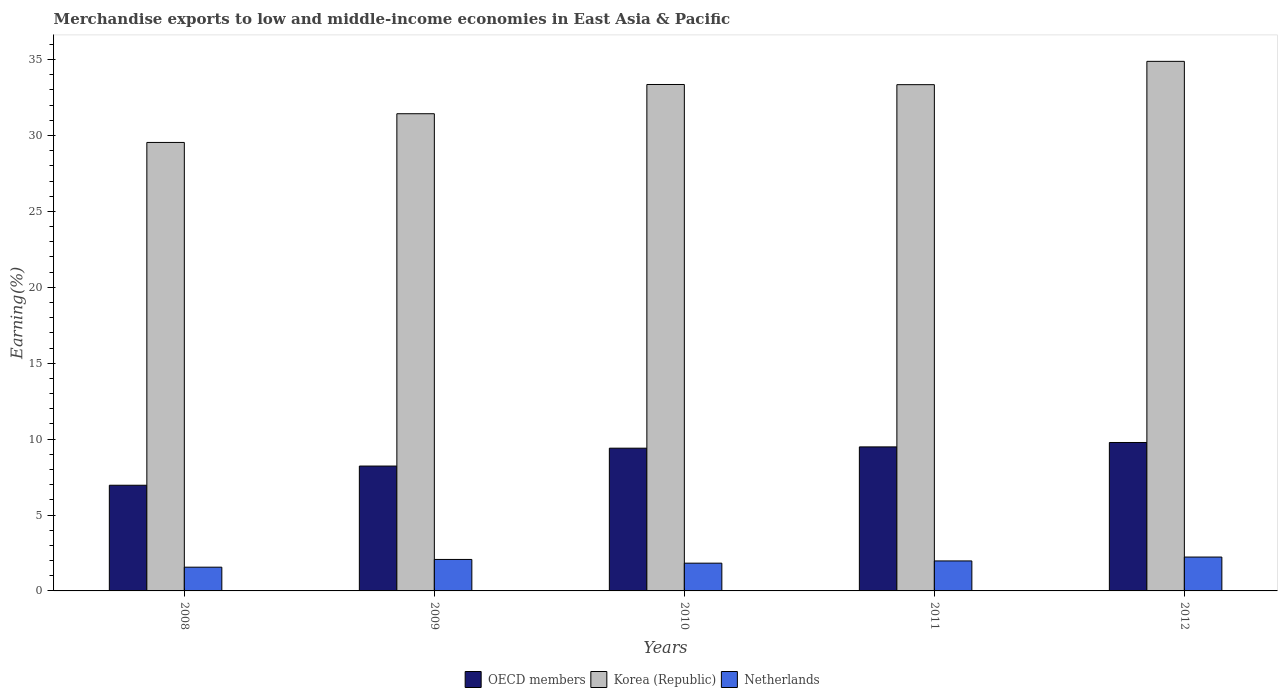How many different coloured bars are there?
Make the answer very short. 3. How many groups of bars are there?
Provide a short and direct response. 5. How many bars are there on the 1st tick from the left?
Your answer should be very brief. 3. What is the percentage of amount earned from merchandise exports in OECD members in 2012?
Offer a terse response. 9.78. Across all years, what is the maximum percentage of amount earned from merchandise exports in OECD members?
Offer a terse response. 9.78. Across all years, what is the minimum percentage of amount earned from merchandise exports in Korea (Republic)?
Keep it short and to the point. 29.54. In which year was the percentage of amount earned from merchandise exports in Netherlands minimum?
Keep it short and to the point. 2008. What is the total percentage of amount earned from merchandise exports in OECD members in the graph?
Ensure brevity in your answer.  43.85. What is the difference between the percentage of amount earned from merchandise exports in Netherlands in 2009 and that in 2011?
Offer a very short reply. 0.1. What is the difference between the percentage of amount earned from merchandise exports in Korea (Republic) in 2008 and the percentage of amount earned from merchandise exports in OECD members in 2009?
Make the answer very short. 21.32. What is the average percentage of amount earned from merchandise exports in Korea (Republic) per year?
Keep it short and to the point. 32.51. In the year 2009, what is the difference between the percentage of amount earned from merchandise exports in Korea (Republic) and percentage of amount earned from merchandise exports in Netherlands?
Offer a terse response. 29.36. What is the ratio of the percentage of amount earned from merchandise exports in Netherlands in 2010 to that in 2011?
Provide a succinct answer. 0.93. Is the difference between the percentage of amount earned from merchandise exports in Korea (Republic) in 2009 and 2010 greater than the difference between the percentage of amount earned from merchandise exports in Netherlands in 2009 and 2010?
Provide a short and direct response. No. What is the difference between the highest and the second highest percentage of amount earned from merchandise exports in OECD members?
Give a very brief answer. 0.29. What is the difference between the highest and the lowest percentage of amount earned from merchandise exports in Netherlands?
Your answer should be compact. 0.67. What does the 3rd bar from the left in 2011 represents?
Your answer should be compact. Netherlands. What does the 2nd bar from the right in 2011 represents?
Your answer should be compact. Korea (Republic). Is it the case that in every year, the sum of the percentage of amount earned from merchandise exports in Korea (Republic) and percentage of amount earned from merchandise exports in Netherlands is greater than the percentage of amount earned from merchandise exports in OECD members?
Provide a succinct answer. Yes. How many bars are there?
Offer a very short reply. 15. Are the values on the major ticks of Y-axis written in scientific E-notation?
Offer a very short reply. No. Does the graph contain grids?
Provide a succinct answer. No. Where does the legend appear in the graph?
Your answer should be compact. Bottom center. How many legend labels are there?
Your answer should be compact. 3. What is the title of the graph?
Keep it short and to the point. Merchandise exports to low and middle-income economies in East Asia & Pacific. What is the label or title of the X-axis?
Your answer should be very brief. Years. What is the label or title of the Y-axis?
Your answer should be compact. Earning(%). What is the Earning(%) of OECD members in 2008?
Give a very brief answer. 6.96. What is the Earning(%) of Korea (Republic) in 2008?
Keep it short and to the point. 29.54. What is the Earning(%) in Netherlands in 2008?
Your response must be concise. 1.56. What is the Earning(%) of OECD members in 2009?
Provide a short and direct response. 8.22. What is the Earning(%) of Korea (Republic) in 2009?
Your answer should be very brief. 31.43. What is the Earning(%) in Netherlands in 2009?
Your answer should be very brief. 2.07. What is the Earning(%) in OECD members in 2010?
Keep it short and to the point. 9.4. What is the Earning(%) in Korea (Republic) in 2010?
Ensure brevity in your answer.  33.36. What is the Earning(%) in Netherlands in 2010?
Make the answer very short. 1.83. What is the Earning(%) of OECD members in 2011?
Offer a terse response. 9.49. What is the Earning(%) of Korea (Republic) in 2011?
Offer a terse response. 33.35. What is the Earning(%) in Netherlands in 2011?
Offer a terse response. 1.98. What is the Earning(%) in OECD members in 2012?
Give a very brief answer. 9.78. What is the Earning(%) of Korea (Republic) in 2012?
Ensure brevity in your answer.  34.88. What is the Earning(%) of Netherlands in 2012?
Your answer should be very brief. 2.23. Across all years, what is the maximum Earning(%) of OECD members?
Give a very brief answer. 9.78. Across all years, what is the maximum Earning(%) of Korea (Republic)?
Keep it short and to the point. 34.88. Across all years, what is the maximum Earning(%) in Netherlands?
Offer a terse response. 2.23. Across all years, what is the minimum Earning(%) of OECD members?
Your answer should be very brief. 6.96. Across all years, what is the minimum Earning(%) in Korea (Republic)?
Your response must be concise. 29.54. Across all years, what is the minimum Earning(%) of Netherlands?
Offer a terse response. 1.56. What is the total Earning(%) in OECD members in the graph?
Your answer should be compact. 43.85. What is the total Earning(%) in Korea (Republic) in the graph?
Your answer should be very brief. 162.56. What is the total Earning(%) of Netherlands in the graph?
Your answer should be compact. 9.67. What is the difference between the Earning(%) in OECD members in 2008 and that in 2009?
Offer a terse response. -1.26. What is the difference between the Earning(%) of Korea (Republic) in 2008 and that in 2009?
Offer a very short reply. -1.89. What is the difference between the Earning(%) in Netherlands in 2008 and that in 2009?
Keep it short and to the point. -0.51. What is the difference between the Earning(%) of OECD members in 2008 and that in 2010?
Your answer should be compact. -2.44. What is the difference between the Earning(%) of Korea (Republic) in 2008 and that in 2010?
Keep it short and to the point. -3.82. What is the difference between the Earning(%) in Netherlands in 2008 and that in 2010?
Your response must be concise. -0.26. What is the difference between the Earning(%) of OECD members in 2008 and that in 2011?
Provide a succinct answer. -2.53. What is the difference between the Earning(%) of Korea (Republic) in 2008 and that in 2011?
Make the answer very short. -3.81. What is the difference between the Earning(%) in Netherlands in 2008 and that in 2011?
Your response must be concise. -0.41. What is the difference between the Earning(%) in OECD members in 2008 and that in 2012?
Your answer should be very brief. -2.82. What is the difference between the Earning(%) in Korea (Republic) in 2008 and that in 2012?
Ensure brevity in your answer.  -5.34. What is the difference between the Earning(%) in Netherlands in 2008 and that in 2012?
Your answer should be compact. -0.67. What is the difference between the Earning(%) in OECD members in 2009 and that in 2010?
Provide a succinct answer. -1.18. What is the difference between the Earning(%) in Korea (Republic) in 2009 and that in 2010?
Provide a succinct answer. -1.93. What is the difference between the Earning(%) in Netherlands in 2009 and that in 2010?
Your answer should be very brief. 0.24. What is the difference between the Earning(%) of OECD members in 2009 and that in 2011?
Give a very brief answer. -1.26. What is the difference between the Earning(%) of Korea (Republic) in 2009 and that in 2011?
Keep it short and to the point. -1.91. What is the difference between the Earning(%) in Netherlands in 2009 and that in 2011?
Provide a succinct answer. 0.1. What is the difference between the Earning(%) in OECD members in 2009 and that in 2012?
Provide a short and direct response. -1.55. What is the difference between the Earning(%) of Korea (Republic) in 2009 and that in 2012?
Ensure brevity in your answer.  -3.45. What is the difference between the Earning(%) in Netherlands in 2009 and that in 2012?
Your answer should be very brief. -0.16. What is the difference between the Earning(%) in OECD members in 2010 and that in 2011?
Provide a short and direct response. -0.08. What is the difference between the Earning(%) of Korea (Republic) in 2010 and that in 2011?
Provide a succinct answer. 0.01. What is the difference between the Earning(%) of Netherlands in 2010 and that in 2011?
Your answer should be very brief. -0.15. What is the difference between the Earning(%) in OECD members in 2010 and that in 2012?
Your answer should be compact. -0.37. What is the difference between the Earning(%) in Korea (Republic) in 2010 and that in 2012?
Your answer should be very brief. -1.52. What is the difference between the Earning(%) of Netherlands in 2010 and that in 2012?
Provide a short and direct response. -0.4. What is the difference between the Earning(%) in OECD members in 2011 and that in 2012?
Give a very brief answer. -0.29. What is the difference between the Earning(%) of Korea (Republic) in 2011 and that in 2012?
Offer a terse response. -1.54. What is the difference between the Earning(%) in Netherlands in 2011 and that in 2012?
Offer a terse response. -0.26. What is the difference between the Earning(%) in OECD members in 2008 and the Earning(%) in Korea (Republic) in 2009?
Give a very brief answer. -24.47. What is the difference between the Earning(%) in OECD members in 2008 and the Earning(%) in Netherlands in 2009?
Keep it short and to the point. 4.89. What is the difference between the Earning(%) of Korea (Republic) in 2008 and the Earning(%) of Netherlands in 2009?
Your answer should be compact. 27.47. What is the difference between the Earning(%) of OECD members in 2008 and the Earning(%) of Korea (Republic) in 2010?
Keep it short and to the point. -26.4. What is the difference between the Earning(%) of OECD members in 2008 and the Earning(%) of Netherlands in 2010?
Give a very brief answer. 5.13. What is the difference between the Earning(%) in Korea (Republic) in 2008 and the Earning(%) in Netherlands in 2010?
Offer a terse response. 27.71. What is the difference between the Earning(%) in OECD members in 2008 and the Earning(%) in Korea (Republic) in 2011?
Make the answer very short. -26.38. What is the difference between the Earning(%) of OECD members in 2008 and the Earning(%) of Netherlands in 2011?
Make the answer very short. 4.99. What is the difference between the Earning(%) in Korea (Republic) in 2008 and the Earning(%) in Netherlands in 2011?
Keep it short and to the point. 27.56. What is the difference between the Earning(%) in OECD members in 2008 and the Earning(%) in Korea (Republic) in 2012?
Your response must be concise. -27.92. What is the difference between the Earning(%) of OECD members in 2008 and the Earning(%) of Netherlands in 2012?
Make the answer very short. 4.73. What is the difference between the Earning(%) of Korea (Republic) in 2008 and the Earning(%) of Netherlands in 2012?
Your answer should be compact. 27.31. What is the difference between the Earning(%) in OECD members in 2009 and the Earning(%) in Korea (Republic) in 2010?
Your response must be concise. -25.13. What is the difference between the Earning(%) in OECD members in 2009 and the Earning(%) in Netherlands in 2010?
Offer a very short reply. 6.4. What is the difference between the Earning(%) in Korea (Republic) in 2009 and the Earning(%) in Netherlands in 2010?
Offer a terse response. 29.6. What is the difference between the Earning(%) in OECD members in 2009 and the Earning(%) in Korea (Republic) in 2011?
Your answer should be very brief. -25.12. What is the difference between the Earning(%) of OECD members in 2009 and the Earning(%) of Netherlands in 2011?
Ensure brevity in your answer.  6.25. What is the difference between the Earning(%) in Korea (Republic) in 2009 and the Earning(%) in Netherlands in 2011?
Your answer should be very brief. 29.46. What is the difference between the Earning(%) of OECD members in 2009 and the Earning(%) of Korea (Republic) in 2012?
Offer a very short reply. -26.66. What is the difference between the Earning(%) in OECD members in 2009 and the Earning(%) in Netherlands in 2012?
Provide a succinct answer. 5.99. What is the difference between the Earning(%) of Korea (Republic) in 2009 and the Earning(%) of Netherlands in 2012?
Your response must be concise. 29.2. What is the difference between the Earning(%) of OECD members in 2010 and the Earning(%) of Korea (Republic) in 2011?
Offer a very short reply. -23.94. What is the difference between the Earning(%) in OECD members in 2010 and the Earning(%) in Netherlands in 2011?
Offer a very short reply. 7.43. What is the difference between the Earning(%) of Korea (Republic) in 2010 and the Earning(%) of Netherlands in 2011?
Keep it short and to the point. 31.38. What is the difference between the Earning(%) of OECD members in 2010 and the Earning(%) of Korea (Republic) in 2012?
Your answer should be very brief. -25.48. What is the difference between the Earning(%) in OECD members in 2010 and the Earning(%) in Netherlands in 2012?
Provide a short and direct response. 7.17. What is the difference between the Earning(%) of Korea (Republic) in 2010 and the Earning(%) of Netherlands in 2012?
Keep it short and to the point. 31.13. What is the difference between the Earning(%) of OECD members in 2011 and the Earning(%) of Korea (Republic) in 2012?
Provide a short and direct response. -25.4. What is the difference between the Earning(%) of OECD members in 2011 and the Earning(%) of Netherlands in 2012?
Offer a very short reply. 7.26. What is the difference between the Earning(%) in Korea (Republic) in 2011 and the Earning(%) in Netherlands in 2012?
Give a very brief answer. 31.12. What is the average Earning(%) in OECD members per year?
Offer a terse response. 8.77. What is the average Earning(%) of Korea (Republic) per year?
Your answer should be compact. 32.51. What is the average Earning(%) of Netherlands per year?
Provide a short and direct response. 1.93. In the year 2008, what is the difference between the Earning(%) in OECD members and Earning(%) in Korea (Republic)?
Your answer should be compact. -22.58. In the year 2008, what is the difference between the Earning(%) of OECD members and Earning(%) of Netherlands?
Your response must be concise. 5.4. In the year 2008, what is the difference between the Earning(%) in Korea (Republic) and Earning(%) in Netherlands?
Your answer should be compact. 27.98. In the year 2009, what is the difference between the Earning(%) in OECD members and Earning(%) in Korea (Republic)?
Keep it short and to the point. -23.21. In the year 2009, what is the difference between the Earning(%) in OECD members and Earning(%) in Netherlands?
Your answer should be very brief. 6.15. In the year 2009, what is the difference between the Earning(%) in Korea (Republic) and Earning(%) in Netherlands?
Provide a short and direct response. 29.36. In the year 2010, what is the difference between the Earning(%) of OECD members and Earning(%) of Korea (Republic)?
Your answer should be compact. -23.95. In the year 2010, what is the difference between the Earning(%) in OECD members and Earning(%) in Netherlands?
Provide a short and direct response. 7.57. In the year 2010, what is the difference between the Earning(%) of Korea (Republic) and Earning(%) of Netherlands?
Your answer should be compact. 31.53. In the year 2011, what is the difference between the Earning(%) of OECD members and Earning(%) of Korea (Republic)?
Make the answer very short. -23.86. In the year 2011, what is the difference between the Earning(%) in OECD members and Earning(%) in Netherlands?
Your response must be concise. 7.51. In the year 2011, what is the difference between the Earning(%) of Korea (Republic) and Earning(%) of Netherlands?
Keep it short and to the point. 31.37. In the year 2012, what is the difference between the Earning(%) in OECD members and Earning(%) in Korea (Republic)?
Your answer should be compact. -25.1. In the year 2012, what is the difference between the Earning(%) of OECD members and Earning(%) of Netherlands?
Offer a terse response. 7.55. In the year 2012, what is the difference between the Earning(%) in Korea (Republic) and Earning(%) in Netherlands?
Offer a terse response. 32.65. What is the ratio of the Earning(%) in OECD members in 2008 to that in 2009?
Your response must be concise. 0.85. What is the ratio of the Earning(%) in Korea (Republic) in 2008 to that in 2009?
Keep it short and to the point. 0.94. What is the ratio of the Earning(%) in Netherlands in 2008 to that in 2009?
Make the answer very short. 0.75. What is the ratio of the Earning(%) in OECD members in 2008 to that in 2010?
Ensure brevity in your answer.  0.74. What is the ratio of the Earning(%) in Korea (Republic) in 2008 to that in 2010?
Your answer should be compact. 0.89. What is the ratio of the Earning(%) in Netherlands in 2008 to that in 2010?
Your answer should be compact. 0.86. What is the ratio of the Earning(%) of OECD members in 2008 to that in 2011?
Your answer should be compact. 0.73. What is the ratio of the Earning(%) of Korea (Republic) in 2008 to that in 2011?
Provide a short and direct response. 0.89. What is the ratio of the Earning(%) of Netherlands in 2008 to that in 2011?
Offer a terse response. 0.79. What is the ratio of the Earning(%) of OECD members in 2008 to that in 2012?
Offer a very short reply. 0.71. What is the ratio of the Earning(%) of Korea (Republic) in 2008 to that in 2012?
Keep it short and to the point. 0.85. What is the ratio of the Earning(%) in Netherlands in 2008 to that in 2012?
Your answer should be very brief. 0.7. What is the ratio of the Earning(%) in OECD members in 2009 to that in 2010?
Keep it short and to the point. 0.87. What is the ratio of the Earning(%) of Korea (Republic) in 2009 to that in 2010?
Keep it short and to the point. 0.94. What is the ratio of the Earning(%) in Netherlands in 2009 to that in 2010?
Ensure brevity in your answer.  1.13. What is the ratio of the Earning(%) in OECD members in 2009 to that in 2011?
Provide a succinct answer. 0.87. What is the ratio of the Earning(%) in Korea (Republic) in 2009 to that in 2011?
Make the answer very short. 0.94. What is the ratio of the Earning(%) in Netherlands in 2009 to that in 2011?
Provide a short and direct response. 1.05. What is the ratio of the Earning(%) of OECD members in 2009 to that in 2012?
Make the answer very short. 0.84. What is the ratio of the Earning(%) in Korea (Republic) in 2009 to that in 2012?
Your answer should be compact. 0.9. What is the ratio of the Earning(%) of Netherlands in 2009 to that in 2012?
Provide a succinct answer. 0.93. What is the ratio of the Earning(%) of OECD members in 2010 to that in 2011?
Ensure brevity in your answer.  0.99. What is the ratio of the Earning(%) of Korea (Republic) in 2010 to that in 2011?
Your answer should be very brief. 1. What is the ratio of the Earning(%) of Netherlands in 2010 to that in 2011?
Offer a very short reply. 0.93. What is the ratio of the Earning(%) in OECD members in 2010 to that in 2012?
Provide a short and direct response. 0.96. What is the ratio of the Earning(%) of Korea (Republic) in 2010 to that in 2012?
Give a very brief answer. 0.96. What is the ratio of the Earning(%) of Netherlands in 2010 to that in 2012?
Your answer should be compact. 0.82. What is the ratio of the Earning(%) in OECD members in 2011 to that in 2012?
Provide a short and direct response. 0.97. What is the ratio of the Earning(%) in Korea (Republic) in 2011 to that in 2012?
Your answer should be compact. 0.96. What is the ratio of the Earning(%) of Netherlands in 2011 to that in 2012?
Your answer should be very brief. 0.89. What is the difference between the highest and the second highest Earning(%) of OECD members?
Provide a succinct answer. 0.29. What is the difference between the highest and the second highest Earning(%) of Korea (Republic)?
Your answer should be very brief. 1.52. What is the difference between the highest and the second highest Earning(%) in Netherlands?
Provide a succinct answer. 0.16. What is the difference between the highest and the lowest Earning(%) in OECD members?
Provide a short and direct response. 2.82. What is the difference between the highest and the lowest Earning(%) of Korea (Republic)?
Provide a succinct answer. 5.34. What is the difference between the highest and the lowest Earning(%) in Netherlands?
Give a very brief answer. 0.67. 